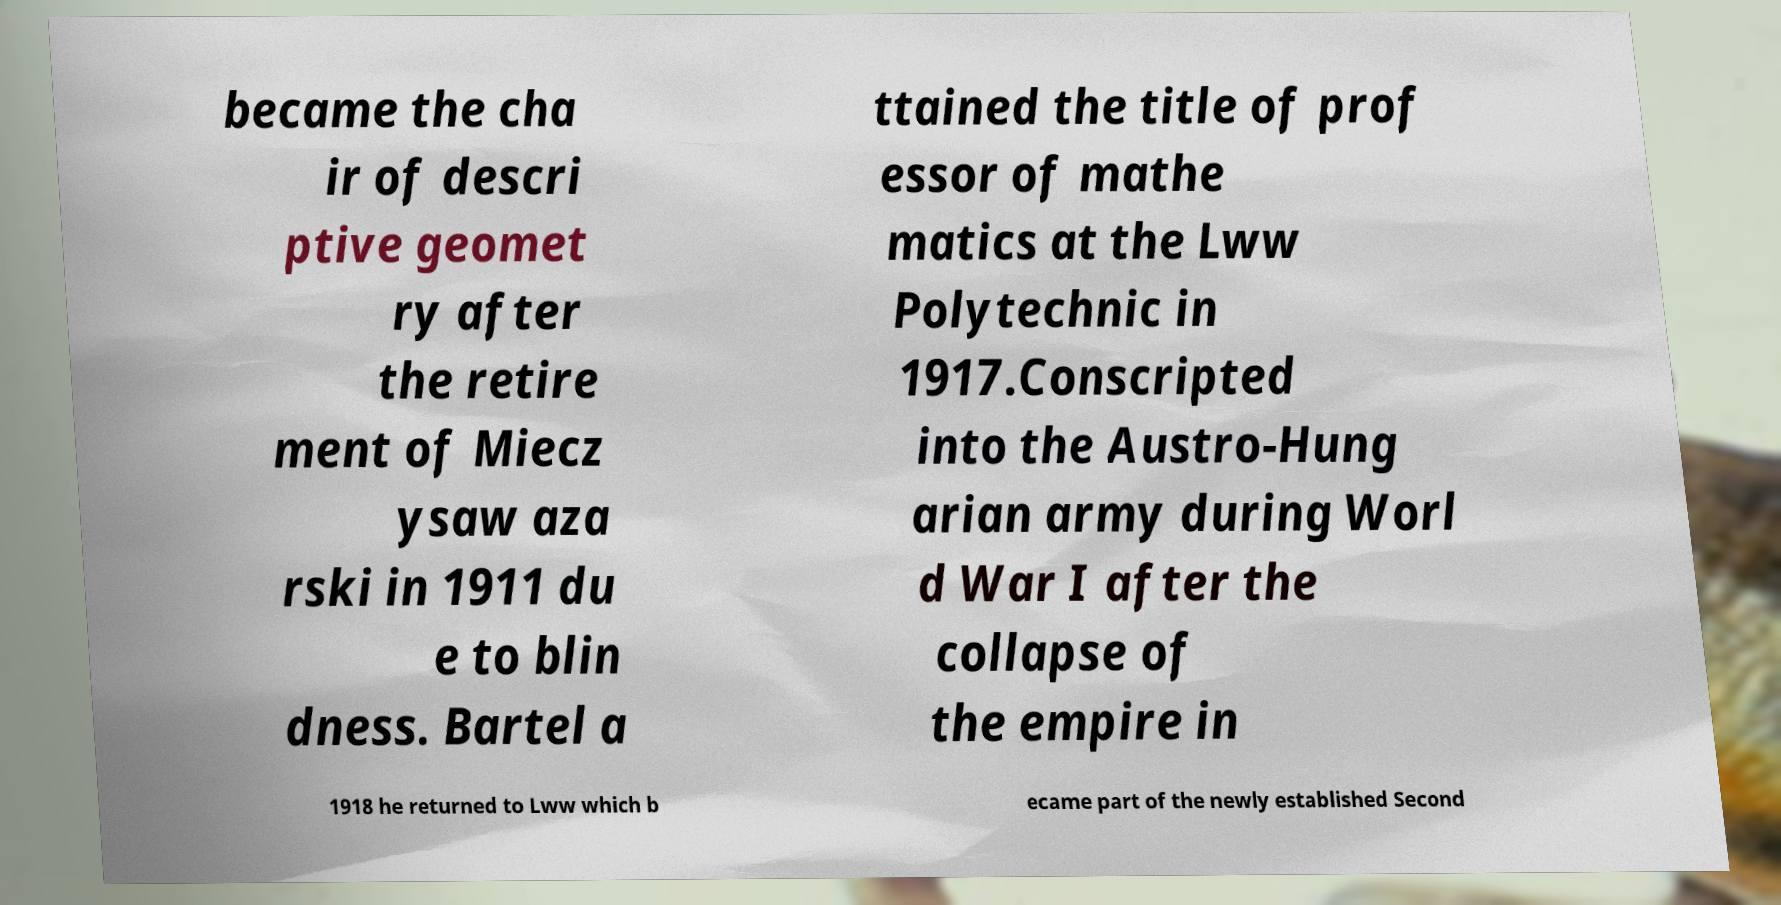I need the written content from this picture converted into text. Can you do that? became the cha ir of descri ptive geomet ry after the retire ment of Miecz ysaw aza rski in 1911 du e to blin dness. Bartel a ttained the title of prof essor of mathe matics at the Lww Polytechnic in 1917.Conscripted into the Austro-Hung arian army during Worl d War I after the collapse of the empire in 1918 he returned to Lww which b ecame part of the newly established Second 